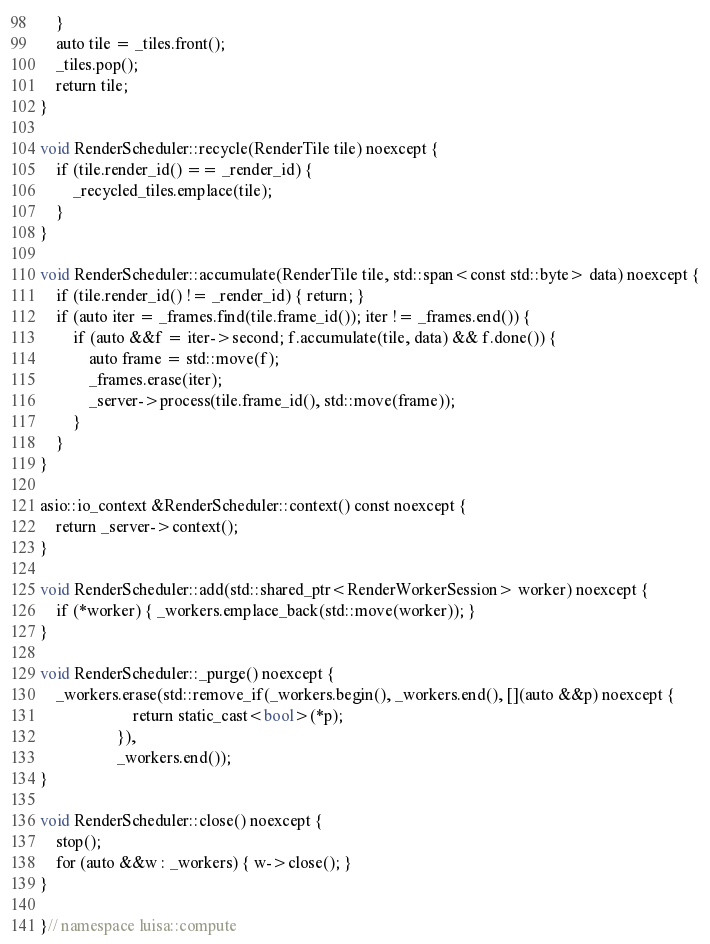<code> <loc_0><loc_0><loc_500><loc_500><_C++_>    }
    auto tile = _tiles.front();
    _tiles.pop();
    return tile;
}

void RenderScheduler::recycle(RenderTile tile) noexcept {
    if (tile.render_id() == _render_id) {
        _recycled_tiles.emplace(tile);
    }
}

void RenderScheduler::accumulate(RenderTile tile, std::span<const std::byte> data) noexcept {
    if (tile.render_id() != _render_id) { return; }
    if (auto iter = _frames.find(tile.frame_id()); iter != _frames.end()) {
        if (auto &&f = iter->second; f.accumulate(tile, data) && f.done()) {
            auto frame = std::move(f);
            _frames.erase(iter);
            _server->process(tile.frame_id(), std::move(frame));
        }
    }
}

asio::io_context &RenderScheduler::context() const noexcept {
    return _server->context();
}

void RenderScheduler::add(std::shared_ptr<RenderWorkerSession> worker) noexcept {
    if (*worker) { _workers.emplace_back(std::move(worker)); }
}

void RenderScheduler::_purge() noexcept {
    _workers.erase(std::remove_if(_workers.begin(), _workers.end(), [](auto &&p) noexcept {
                       return static_cast<bool>(*p);
                   }),
                   _workers.end());
}

void RenderScheduler::close() noexcept {
    stop();
    for (auto &&w : _workers) { w->close(); }
}

}// namespace luisa::compute
</code> 